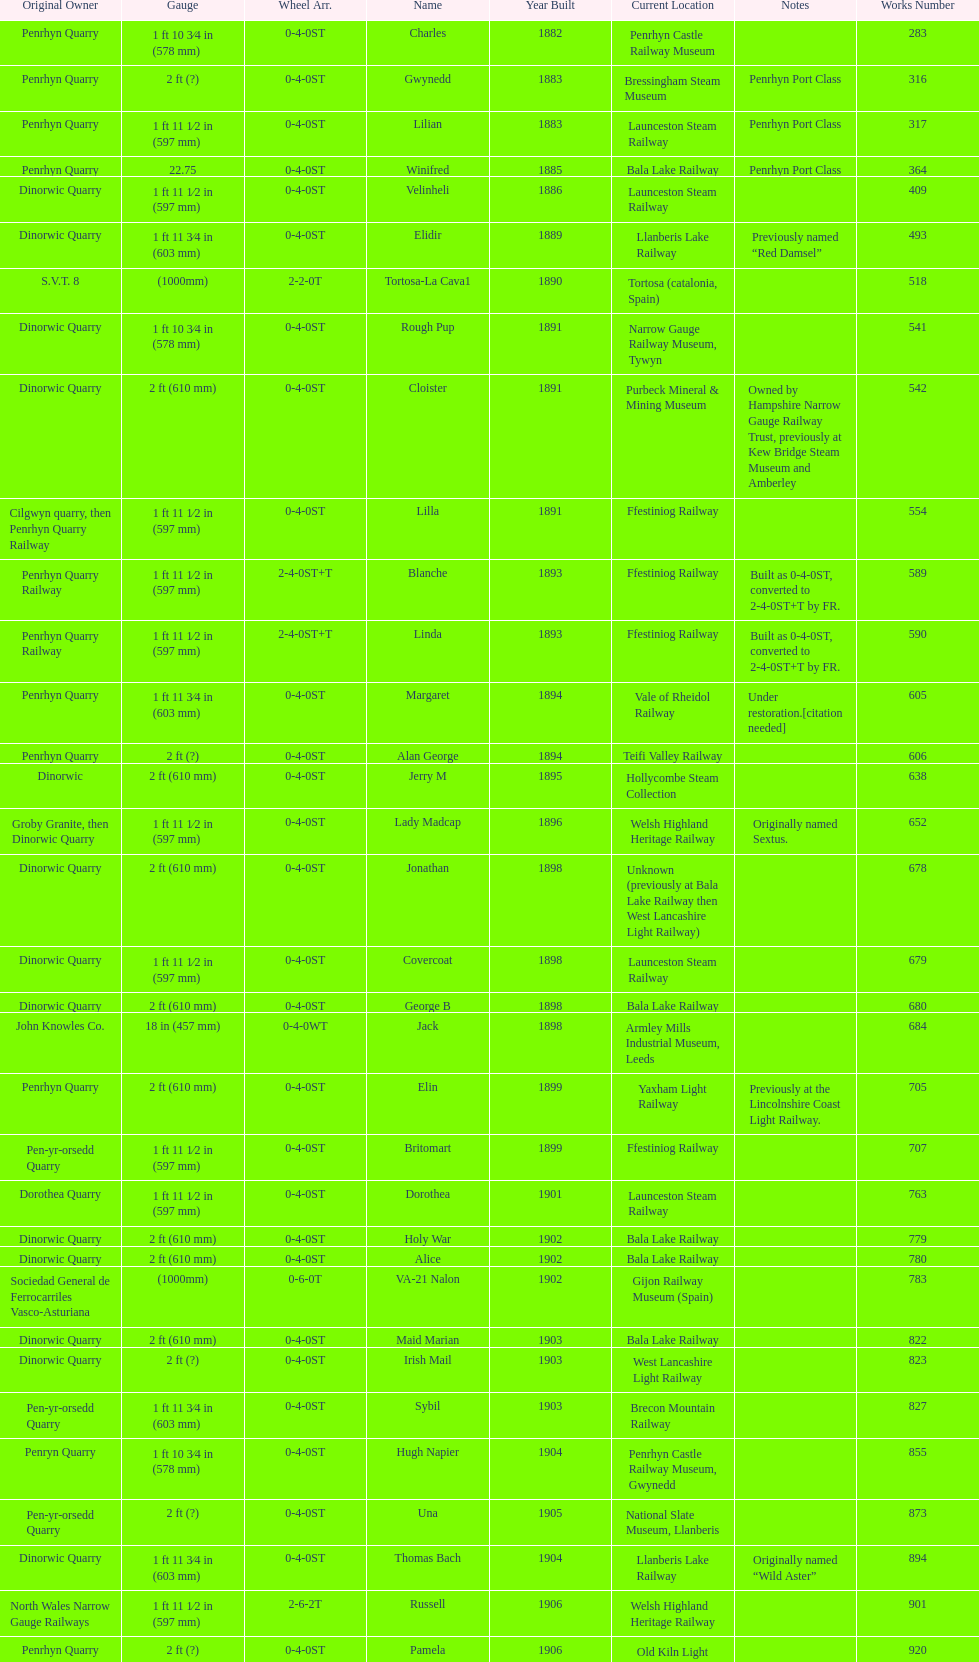How many steam locomotives are currently located at the bala lake railway? 364. 